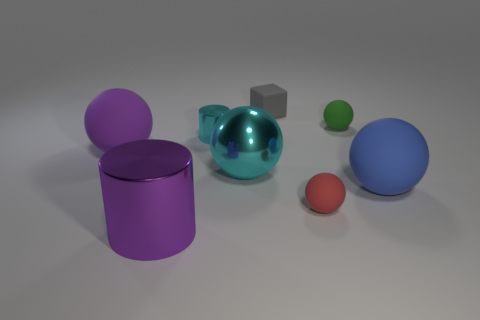Subtract 1 spheres. How many spheres are left? 4 Subtract all cyan balls. How many balls are left? 4 Subtract all small green balls. How many balls are left? 4 Subtract all purple spheres. Subtract all gray cylinders. How many spheres are left? 4 Add 2 large things. How many objects exist? 10 Subtract all spheres. How many objects are left? 3 Subtract 0 purple cubes. How many objects are left? 8 Subtract all large brown rubber blocks. Subtract all tiny gray rubber objects. How many objects are left? 7 Add 2 blue matte objects. How many blue matte objects are left? 3 Add 8 tiny rubber cubes. How many tiny rubber cubes exist? 9 